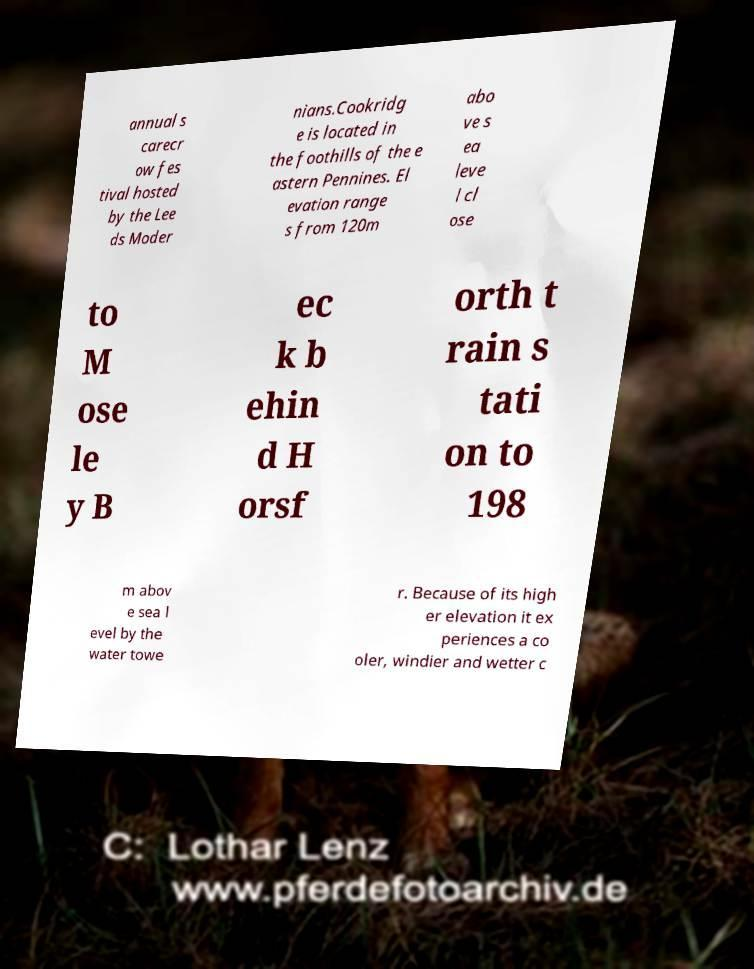Can you accurately transcribe the text from the provided image for me? annual s carecr ow fes tival hosted by the Lee ds Moder nians.Cookridg e is located in the foothills of the e astern Pennines. El evation range s from 120m abo ve s ea leve l cl ose to M ose le y B ec k b ehin d H orsf orth t rain s tati on to 198 m abov e sea l evel by the water towe r. Because of its high er elevation it ex periences a co oler, windier and wetter c 